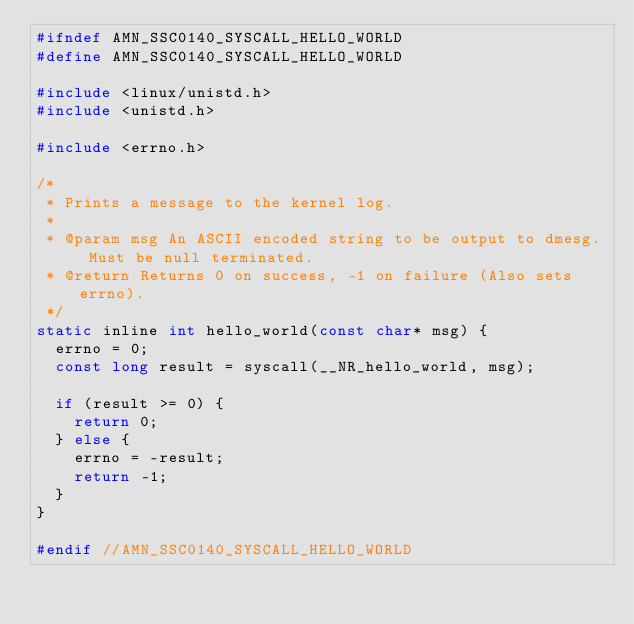<code> <loc_0><loc_0><loc_500><loc_500><_C_>#ifndef AMN_SSC0140_SYSCALL_HELLO_WORLD
#define AMN_SSC0140_SYSCALL_HELLO_WORLD

#include <linux/unistd.h>
#include <unistd.h>

#include <errno.h>

/*
 * Prints a message to the kernel log.
 *
 * @param msg An ASCII encoded string to be output to dmesg. Must be null terminated.  
 * @return Returns 0 on success, -1 on failure (Also sets errno).
 */
static inline int hello_world(const char* msg) {
	errno = 0;
	const long result = syscall(__NR_hello_world, msg);
	
	if (result >= 0) {
		return 0;
	} else {
		errno = -result;
		return -1;
	}
}

#endif //AMN_SSC0140_SYSCALL_HELLO_WORLD
</code> 